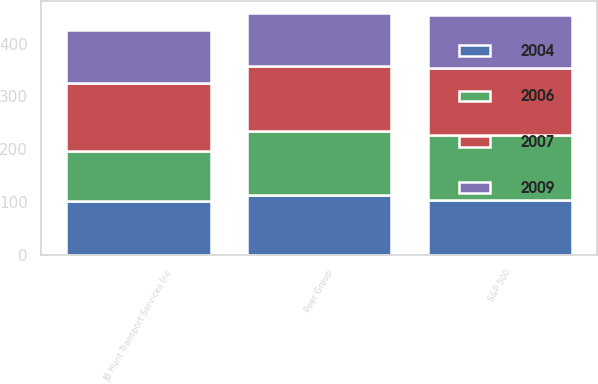Convert chart to OTSL. <chart><loc_0><loc_0><loc_500><loc_500><stacked_bar_chart><ecel><fcel>JB Hunt Transport Services Inc<fcel>S&P 500<fcel>Peer Group<nl><fcel>2009<fcel>100<fcel>100<fcel>100<nl><fcel>2004<fcel>102.15<fcel>104.91<fcel>113.84<nl><fcel>2006<fcel>95.07<fcel>121.48<fcel>120.76<nl><fcel>2007<fcel>127.79<fcel>128.16<fcel>122.69<nl></chart> 